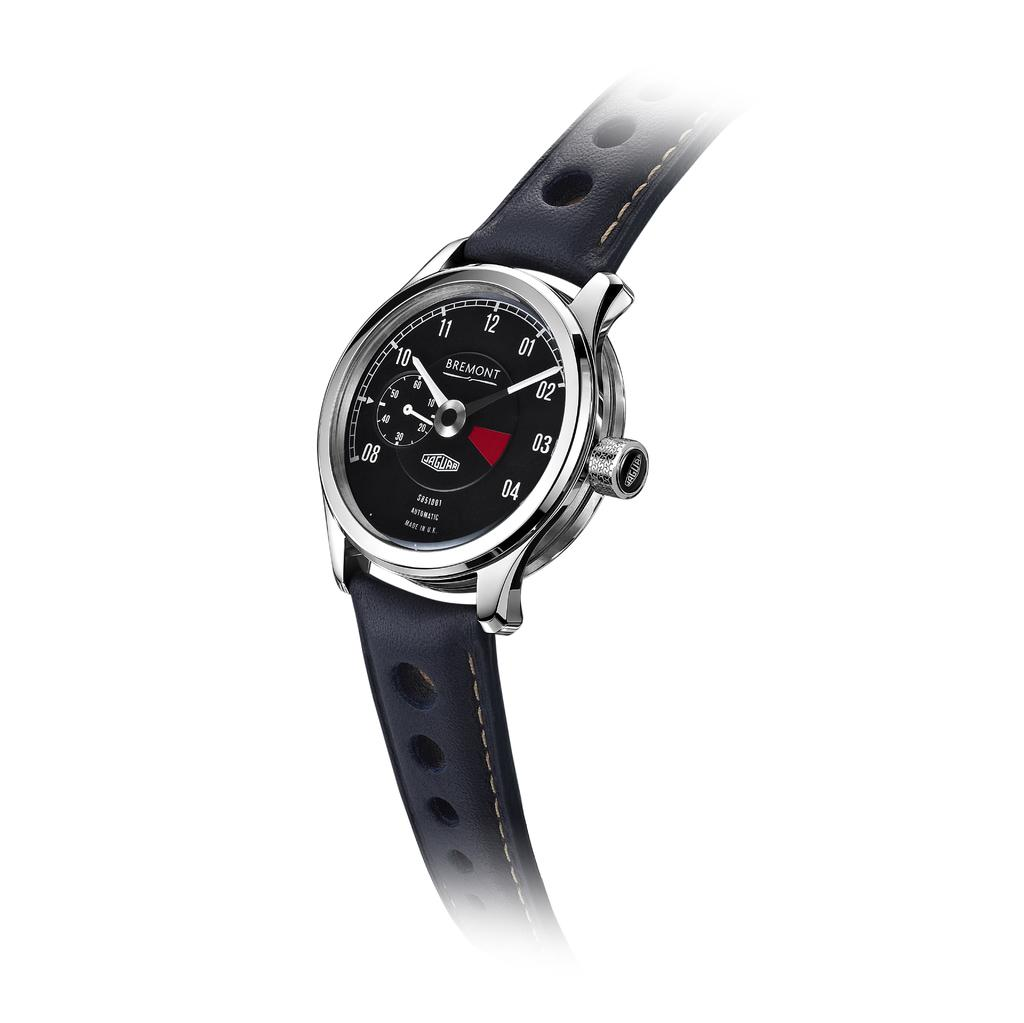Provide a one-sentence caption for the provided image. Black and silver watch which says BREMONT on it. 